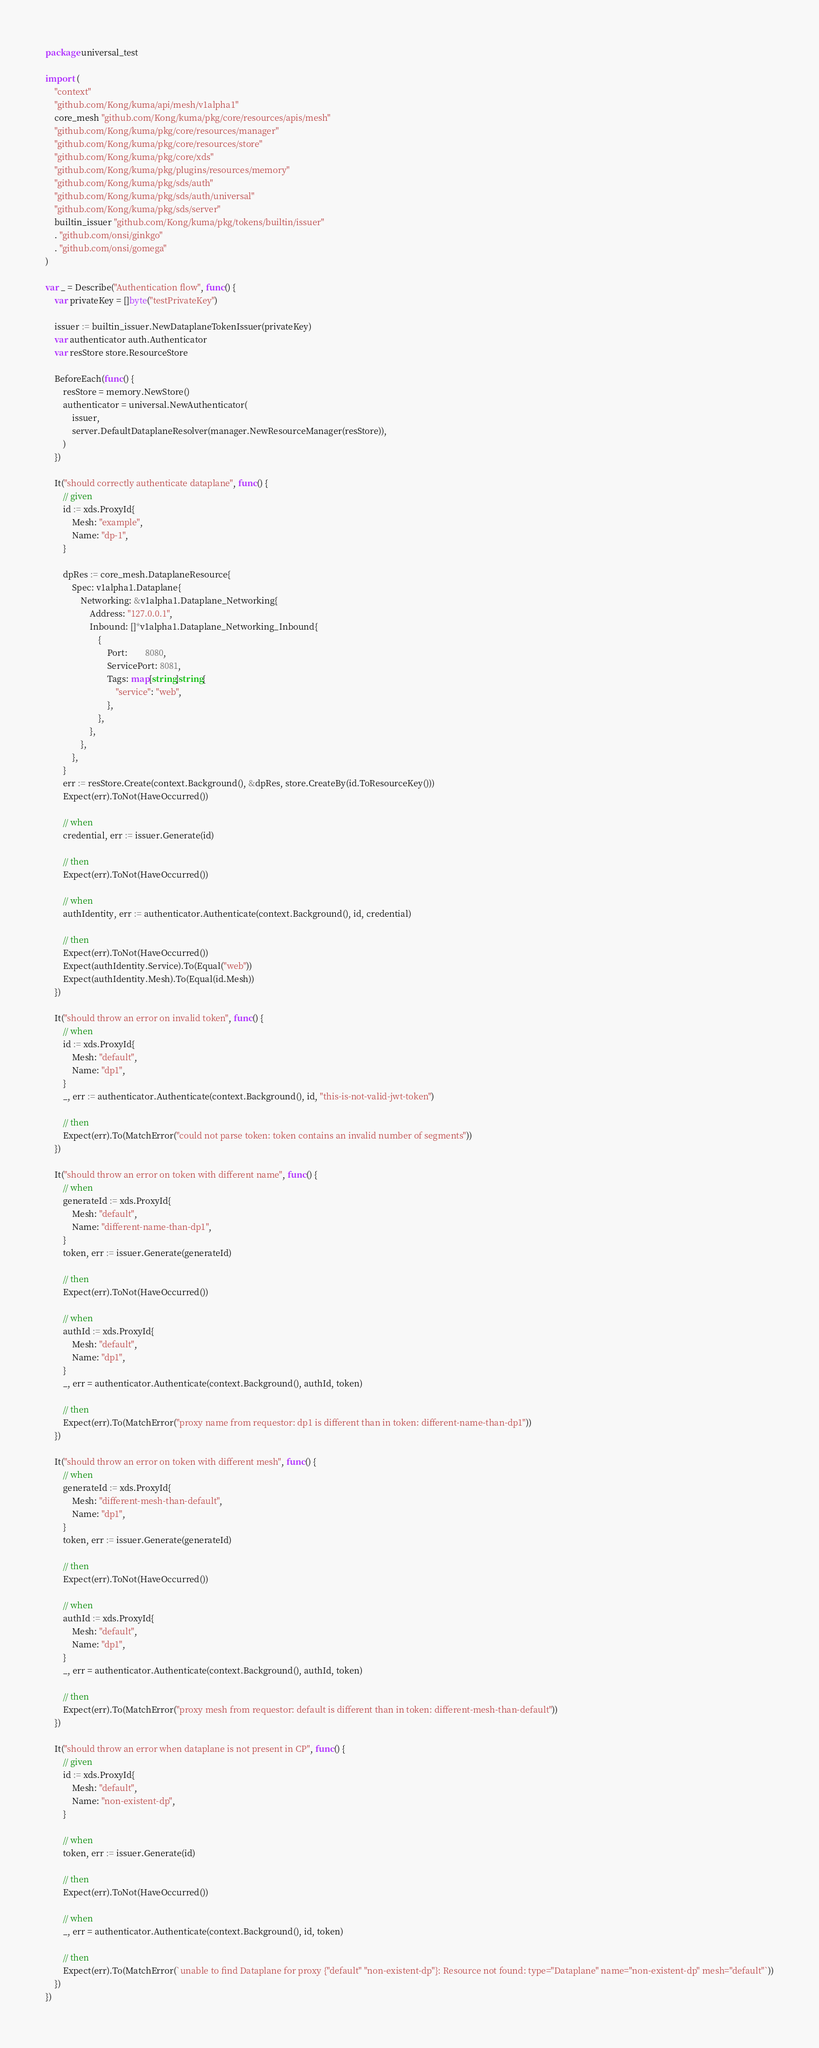Convert code to text. <code><loc_0><loc_0><loc_500><loc_500><_Go_>package universal_test

import (
	"context"
	"github.com/Kong/kuma/api/mesh/v1alpha1"
	core_mesh "github.com/Kong/kuma/pkg/core/resources/apis/mesh"
	"github.com/Kong/kuma/pkg/core/resources/manager"
	"github.com/Kong/kuma/pkg/core/resources/store"
	"github.com/Kong/kuma/pkg/core/xds"
	"github.com/Kong/kuma/pkg/plugins/resources/memory"
	"github.com/Kong/kuma/pkg/sds/auth"
	"github.com/Kong/kuma/pkg/sds/auth/universal"
	"github.com/Kong/kuma/pkg/sds/server"
	builtin_issuer "github.com/Kong/kuma/pkg/tokens/builtin/issuer"
	. "github.com/onsi/ginkgo"
	. "github.com/onsi/gomega"
)

var _ = Describe("Authentication flow", func() {
	var privateKey = []byte("testPrivateKey")

	issuer := builtin_issuer.NewDataplaneTokenIssuer(privateKey)
	var authenticator auth.Authenticator
	var resStore store.ResourceStore

	BeforeEach(func() {
		resStore = memory.NewStore()
		authenticator = universal.NewAuthenticator(
			issuer,
			server.DefaultDataplaneResolver(manager.NewResourceManager(resStore)),
		)
	})

	It("should correctly authenticate dataplane", func() {
		// given
		id := xds.ProxyId{
			Mesh: "example",
			Name: "dp-1",
		}

		dpRes := core_mesh.DataplaneResource{
			Spec: v1alpha1.Dataplane{
				Networking: &v1alpha1.Dataplane_Networking{
					Address: "127.0.0.1",
					Inbound: []*v1alpha1.Dataplane_Networking_Inbound{
						{
							Port:        8080,
							ServicePort: 8081,
							Tags: map[string]string{
								"service": "web",
							},
						},
					},
				},
			},
		}
		err := resStore.Create(context.Background(), &dpRes, store.CreateBy(id.ToResourceKey()))
		Expect(err).ToNot(HaveOccurred())

		// when
		credential, err := issuer.Generate(id)

		// then
		Expect(err).ToNot(HaveOccurred())

		// when
		authIdentity, err := authenticator.Authenticate(context.Background(), id, credential)

		// then
		Expect(err).ToNot(HaveOccurred())
		Expect(authIdentity.Service).To(Equal("web"))
		Expect(authIdentity.Mesh).To(Equal(id.Mesh))
	})

	It("should throw an error on invalid token", func() {
		// when
		id := xds.ProxyId{
			Mesh: "default",
			Name: "dp1",
		}
		_, err := authenticator.Authenticate(context.Background(), id, "this-is-not-valid-jwt-token")

		// then
		Expect(err).To(MatchError("could not parse token: token contains an invalid number of segments"))
	})

	It("should throw an error on token with different name", func() {
		// when
		generateId := xds.ProxyId{
			Mesh: "default",
			Name: "different-name-than-dp1",
		}
		token, err := issuer.Generate(generateId)

		// then
		Expect(err).ToNot(HaveOccurred())

		// when
		authId := xds.ProxyId{
			Mesh: "default",
			Name: "dp1",
		}
		_, err = authenticator.Authenticate(context.Background(), authId, token)

		// then
		Expect(err).To(MatchError("proxy name from requestor: dp1 is different than in token: different-name-than-dp1"))
	})

	It("should throw an error on token with different mesh", func() {
		// when
		generateId := xds.ProxyId{
			Mesh: "different-mesh-than-default",
			Name: "dp1",
		}
		token, err := issuer.Generate(generateId)

		// then
		Expect(err).ToNot(HaveOccurred())

		// when
		authId := xds.ProxyId{
			Mesh: "default",
			Name: "dp1",
		}
		_, err = authenticator.Authenticate(context.Background(), authId, token)

		// then
		Expect(err).To(MatchError("proxy mesh from requestor: default is different than in token: different-mesh-than-default"))
	})

	It("should throw an error when dataplane is not present in CP", func() {
		// given
		id := xds.ProxyId{
			Mesh: "default",
			Name: "non-existent-dp",
		}

		// when
		token, err := issuer.Generate(id)

		// then
		Expect(err).ToNot(HaveOccurred())

		// when
		_, err = authenticator.Authenticate(context.Background(), id, token)

		// then
		Expect(err).To(MatchError(`unable to find Dataplane for proxy {"default" "non-existent-dp"}: Resource not found: type="Dataplane" name="non-existent-dp" mesh="default"`))
	})
})
</code> 